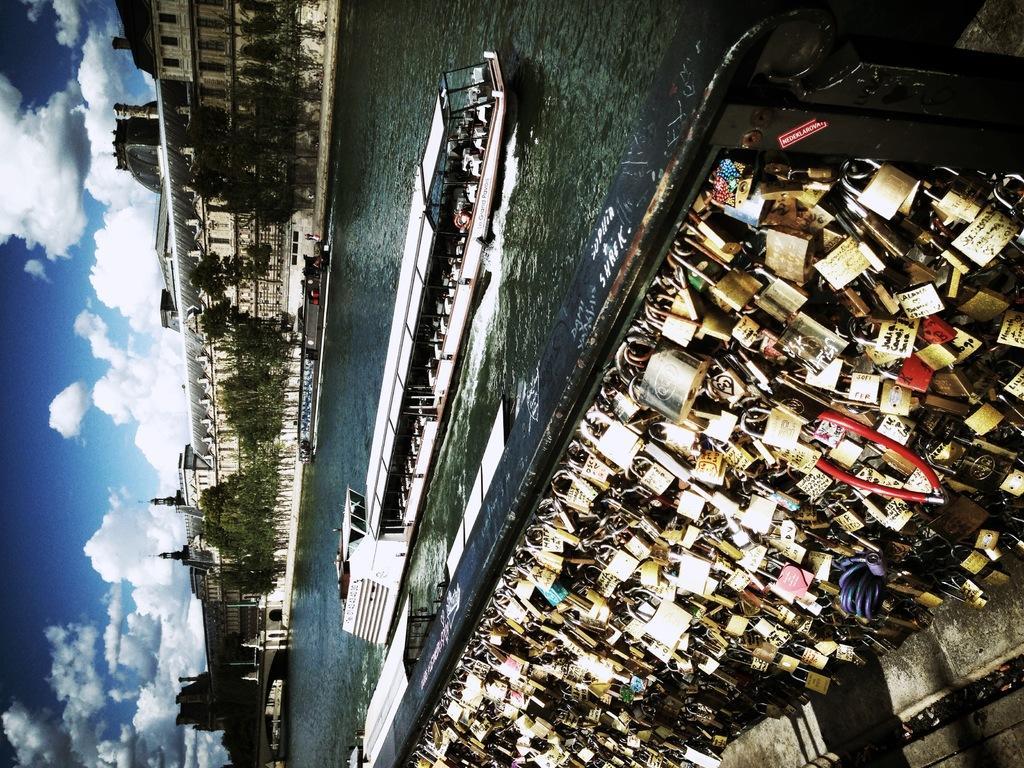Could you give a brief overview of what you see in this image? Here we can see group of locks and we can see ship on the water. background we can see buildings,trees and sky with clouds. 